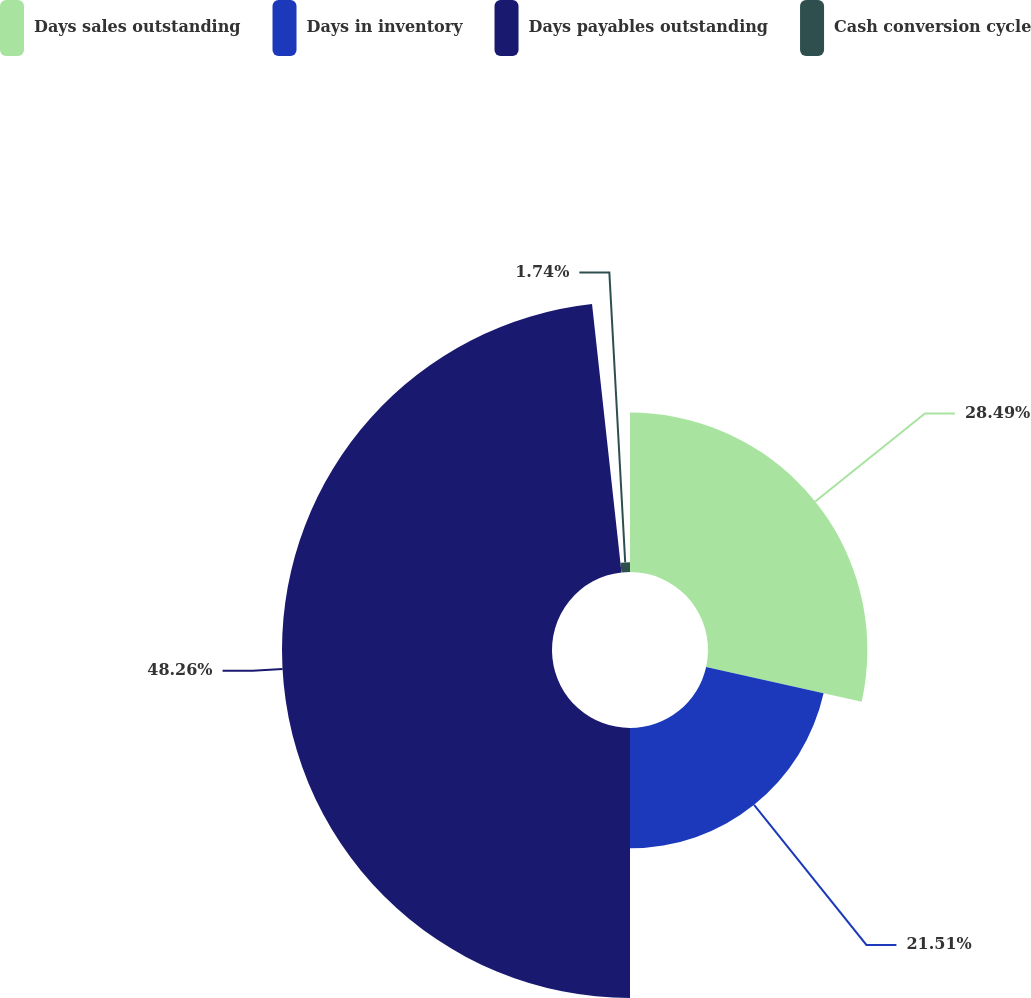Convert chart. <chart><loc_0><loc_0><loc_500><loc_500><pie_chart><fcel>Days sales outstanding<fcel>Days in inventory<fcel>Days payables outstanding<fcel>Cash conversion cycle<nl><fcel>28.49%<fcel>21.51%<fcel>48.26%<fcel>1.74%<nl></chart> 